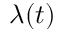<formula> <loc_0><loc_0><loc_500><loc_500>\lambda ( t )</formula> 